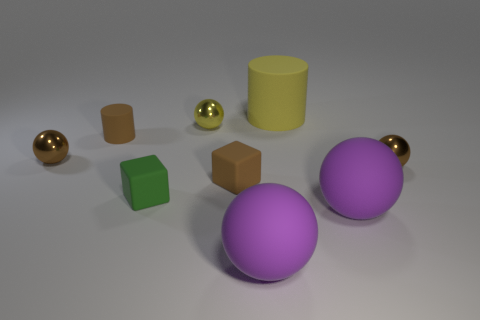Subtract all small brown spheres. How many spheres are left? 3 Subtract all brown cylinders. How many brown spheres are left? 2 Subtract 3 balls. How many balls are left? 2 Add 1 large yellow rubber cylinders. How many objects exist? 10 Subtract all yellow balls. How many balls are left? 4 Subtract all spheres. How many objects are left? 4 Subtract all purple balls. Subtract all brown cylinders. How many balls are left? 3 Add 6 large purple spheres. How many large purple spheres are left? 8 Add 2 green matte blocks. How many green matte blocks exist? 3 Subtract 0 cyan cylinders. How many objects are left? 9 